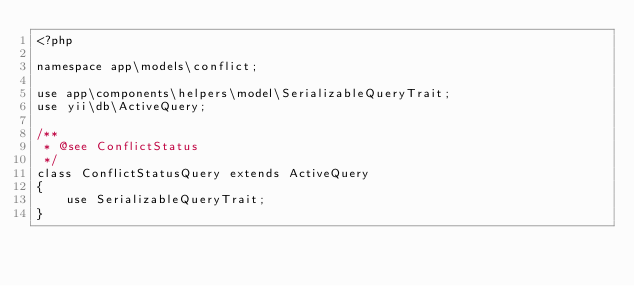<code> <loc_0><loc_0><loc_500><loc_500><_PHP_><?php

namespace app\models\conflict;

use app\components\helpers\model\SerializableQueryTrait;
use yii\db\ActiveQuery;

/**
 * @see ConflictStatus
 */
class ConflictStatusQuery extends ActiveQuery
{
    use SerializableQueryTrait;
}
</code> 